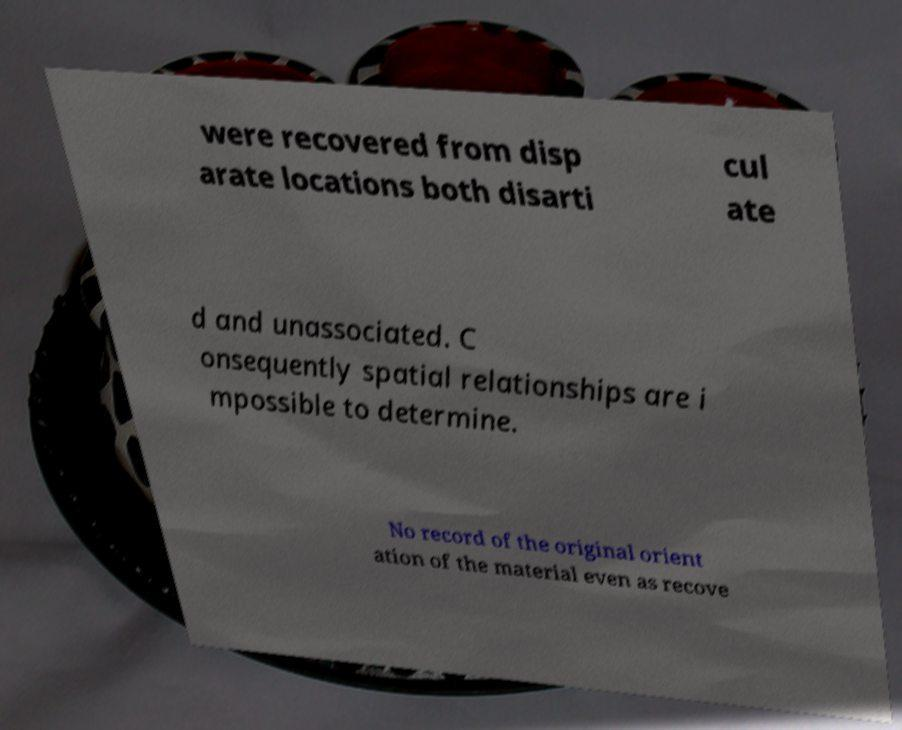Can you accurately transcribe the text from the provided image for me? were recovered from disp arate locations both disarti cul ate d and unassociated. C onsequently spatial relationships are i mpossible to determine. No record of the original orient ation of the material even as recove 